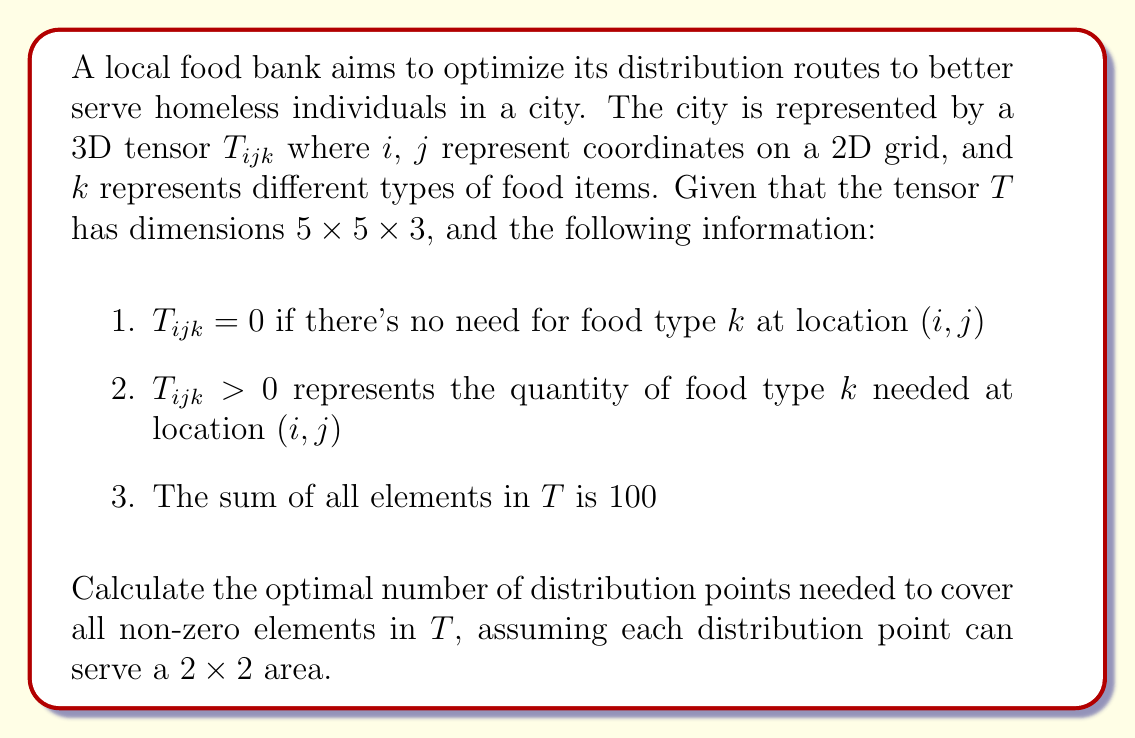Show me your answer to this math problem. Let's approach this step-by-step:

1) First, we need to understand what the tensor $T$ represents:
   - It's a 5x5x3 tensor, meaning it covers a 5x5 grid with 3 types of food items.
   - Non-zero elements indicate locations that need food.

2) To find the optimal number of distribution points, we need to determine the minimum number of 2x2 areas that cover all non-zero elements.

3) In the worst-case scenario, the non-zero elements could be distributed in a way that requires the maximum number of 2x2 areas. This would happen if they were arranged in a checkerboard pattern.

4) In a 5x5 grid, the maximum number of 2x2 areas needed in this worst-case scenario would be:
   $$\left\lceil\frac{5}{2}\right\rceil \times \left\lceil\frac{5}{2}\right\rceil = 3 \times 3 = 9$$

5) However, we're told that the sum of all elements in $T$ is 100. This means that on average, each cell in the 5x5x3 tensor contains:
   $$\frac{100}{5 \times 5 \times 3} = \frac{100}{75} = \frac{4}{3}$$

6) Since each cell on average contains more than 1 unit of food (across all types), we can conclude that most, if not all, cells in the 2D grid will have some food need.

7) Given this information, the optimal number of distribution points will likely be the minimum number needed to cover the entire 5x5 grid.

8) To cover a 5x5 grid with 2x2 areas, we need:
   $$\left\lceil\frac{5}{2}\right\rceil \times \left\lceil\frac{5}{2}\right\rceil = 3 \times 3 = 9$$ distribution points.

Therefore, the optimal number of distribution points needed is 9.
Answer: 9 